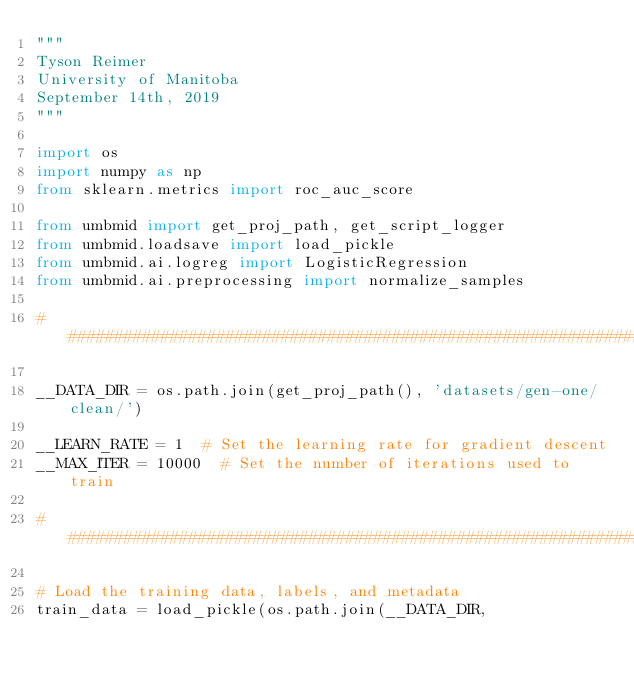Convert code to text. <code><loc_0><loc_0><loc_500><loc_500><_Python_>"""
Tyson Reimer
University of Manitoba
September 14th, 2019
"""

import os
import numpy as np
from sklearn.metrics import roc_auc_score

from umbmid import get_proj_path, get_script_logger
from umbmid.loadsave import load_pickle
from umbmid.ai.logreg import LogisticRegression
from umbmid.ai.preprocessing import normalize_samples

###############################################################################

__DATA_DIR = os.path.join(get_proj_path(), 'datasets/gen-one/clean/')

__LEARN_RATE = 1  # Set the learning rate for gradient descent
__MAX_ITER = 10000  # Set the number of iterations used to train

###############################################################################

# Load the training data, labels, and metadata
train_data = load_pickle(os.path.join(__DATA_DIR,</code> 